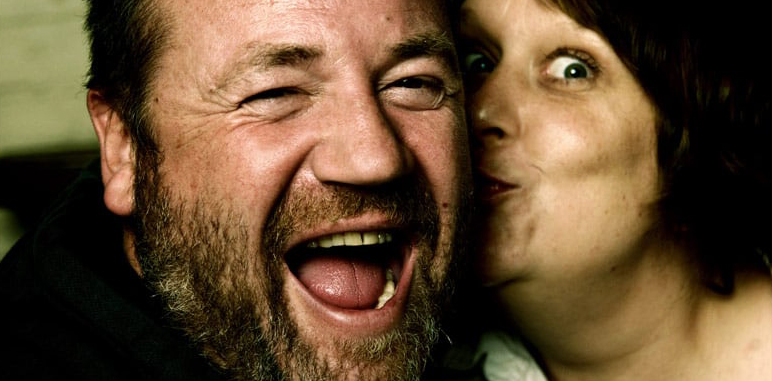What can we infer about their relationship from this image? The close proximity and physical interaction, such as the affectionate kiss, suggest a strong bond and comfort with each other. This could indicate they are good friends, family, or in a close personal relationship, sharing a moment filled with laughter and affection. 